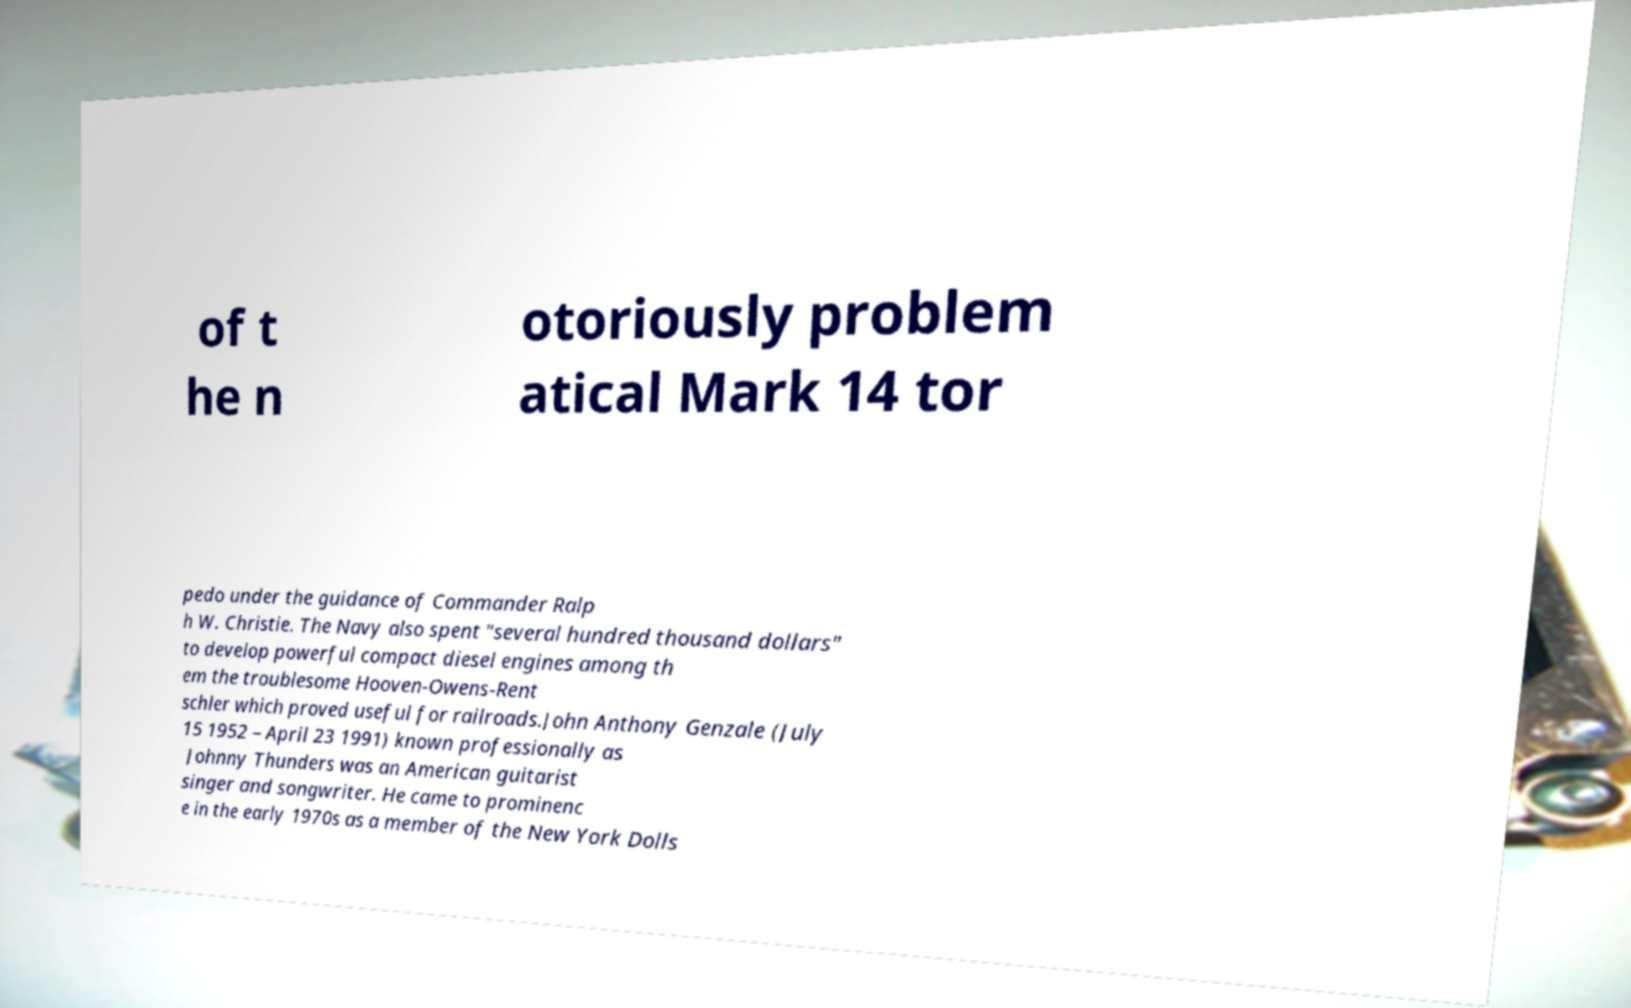I need the written content from this picture converted into text. Can you do that? of t he n otoriously problem atical Mark 14 tor pedo under the guidance of Commander Ralp h W. Christie. The Navy also spent "several hundred thousand dollars" to develop powerful compact diesel engines among th em the troublesome Hooven-Owens-Rent schler which proved useful for railroads.John Anthony Genzale (July 15 1952 – April 23 1991) known professionally as Johnny Thunders was an American guitarist singer and songwriter. He came to prominenc e in the early 1970s as a member of the New York Dolls 